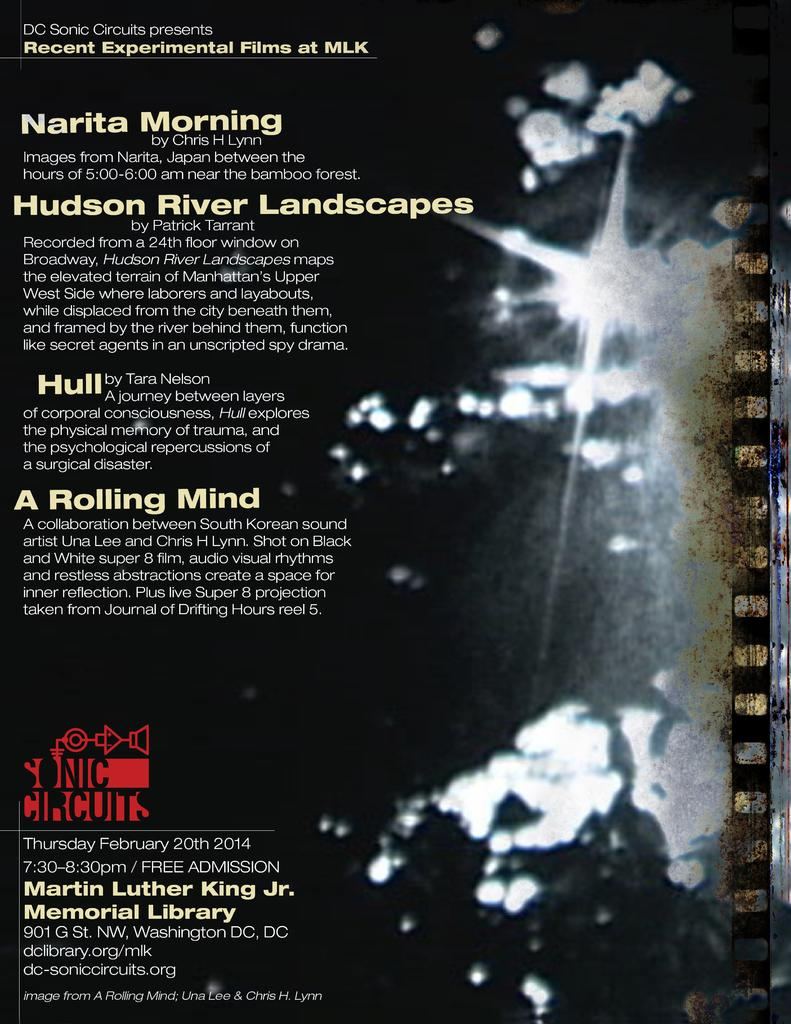Provide a one-sentence caption for the provided image. A flyer for the Hudson River Landscapes. and the MLK Jr. Library. 